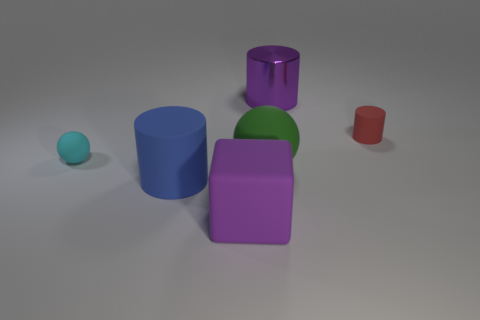What is the size of the rubber ball on the left side of the purple object that is in front of the metallic cylinder?
Offer a terse response. Small. What number of cylinders are the same color as the matte cube?
Provide a succinct answer. 1. What number of other things are there of the same size as the green matte sphere?
Your answer should be very brief. 3. How big is the thing that is both to the right of the blue thing and on the left side of the big green thing?
Your answer should be very brief. Large. What number of other big purple objects have the same shape as the big purple shiny object?
Offer a terse response. 0. What is the material of the small ball?
Your response must be concise. Rubber. Is the shape of the small red thing the same as the purple shiny thing?
Your response must be concise. Yes. Is there a sphere made of the same material as the big blue thing?
Offer a very short reply. Yes. There is a object that is behind the large green rubber sphere and on the left side of the metallic cylinder; what color is it?
Give a very brief answer. Cyan. What material is the purple thing behind the purple cube?
Keep it short and to the point. Metal. 